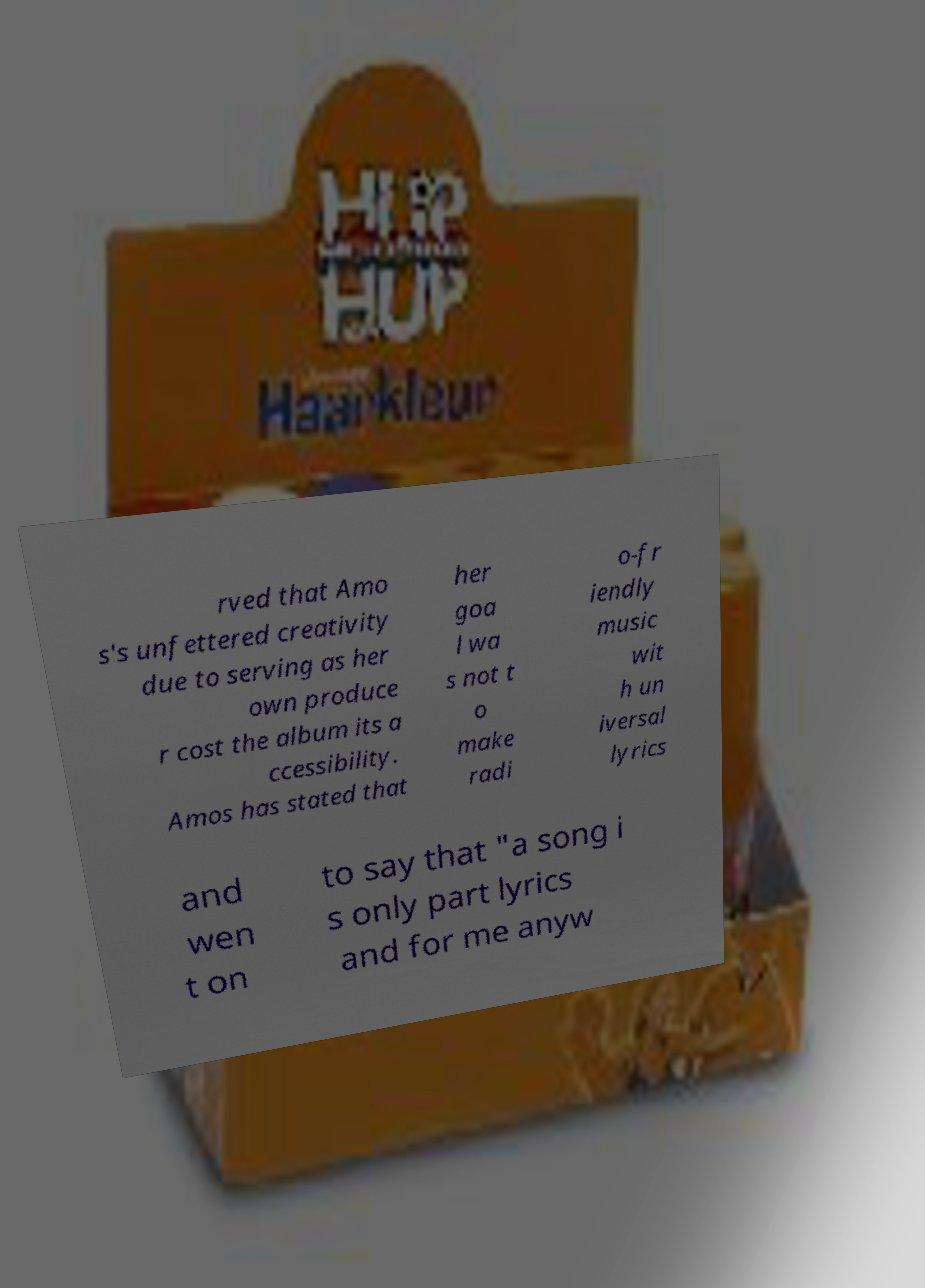For documentation purposes, I need the text within this image transcribed. Could you provide that? rved that Amo s's unfettered creativity due to serving as her own produce r cost the album its a ccessibility. Amos has stated that her goa l wa s not t o make radi o-fr iendly music wit h un iversal lyrics and wen t on to say that "a song i s only part lyrics and for me anyw 